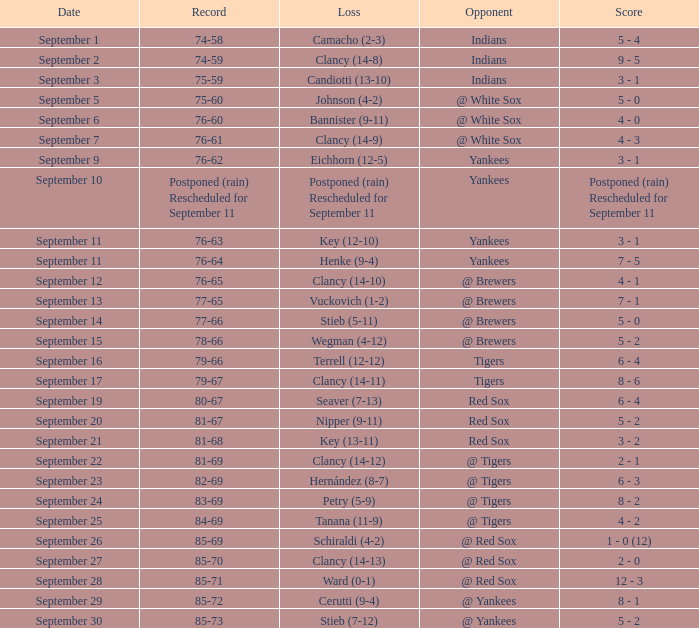What was the date of the game when their record was 84-69? September 25. 